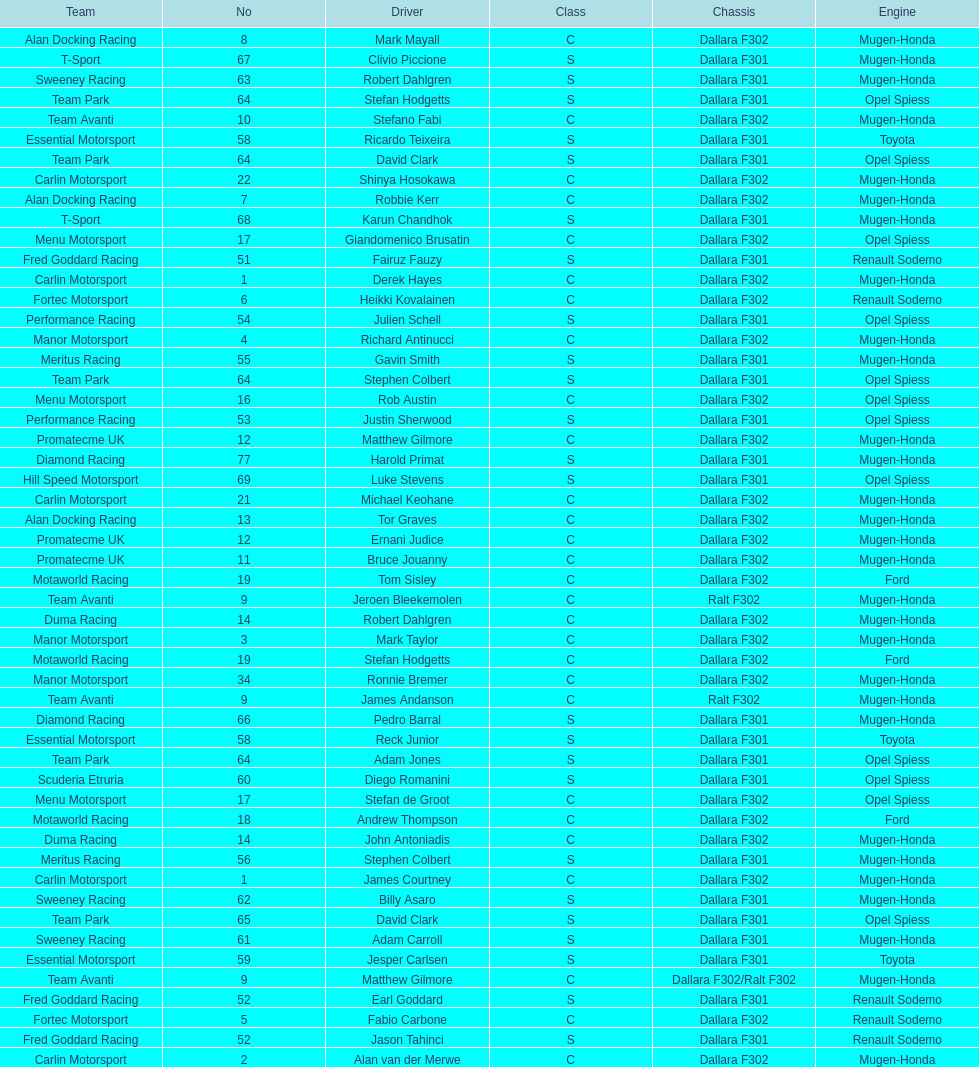The two drivers on t-sport are clivio piccione and what other driver? Karun Chandhok. 